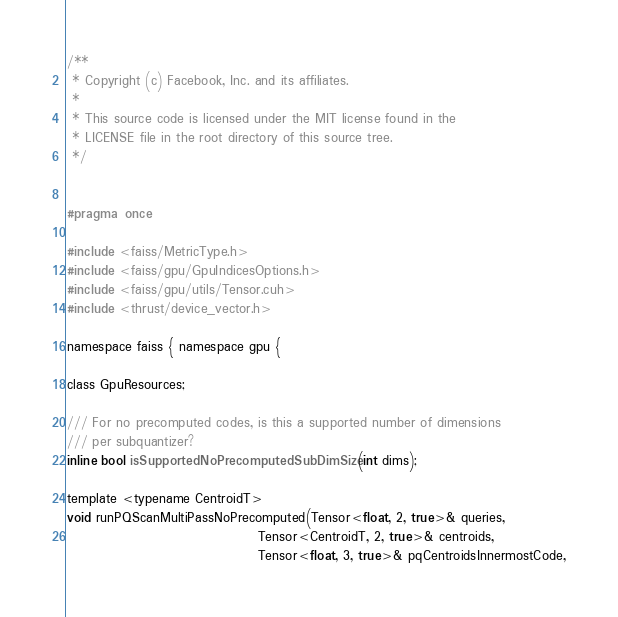<code> <loc_0><loc_0><loc_500><loc_500><_Cuda_>/**
 * Copyright (c) Facebook, Inc. and its affiliates.
 *
 * This source code is licensed under the MIT license found in the
 * LICENSE file in the root directory of this source tree.
 */


#pragma once

#include <faiss/MetricType.h>
#include <faiss/gpu/GpuIndicesOptions.h>
#include <faiss/gpu/utils/Tensor.cuh>
#include <thrust/device_vector.h>

namespace faiss { namespace gpu {

class GpuResources;

/// For no precomputed codes, is this a supported number of dimensions
/// per subquantizer?
inline bool isSupportedNoPrecomputedSubDimSize(int dims);

template <typename CentroidT>
void runPQScanMultiPassNoPrecomputed(Tensor<float, 2, true>& queries,
                                     Tensor<CentroidT, 2, true>& centroids,
                                     Tensor<float, 3, true>& pqCentroidsInnermostCode,</code> 